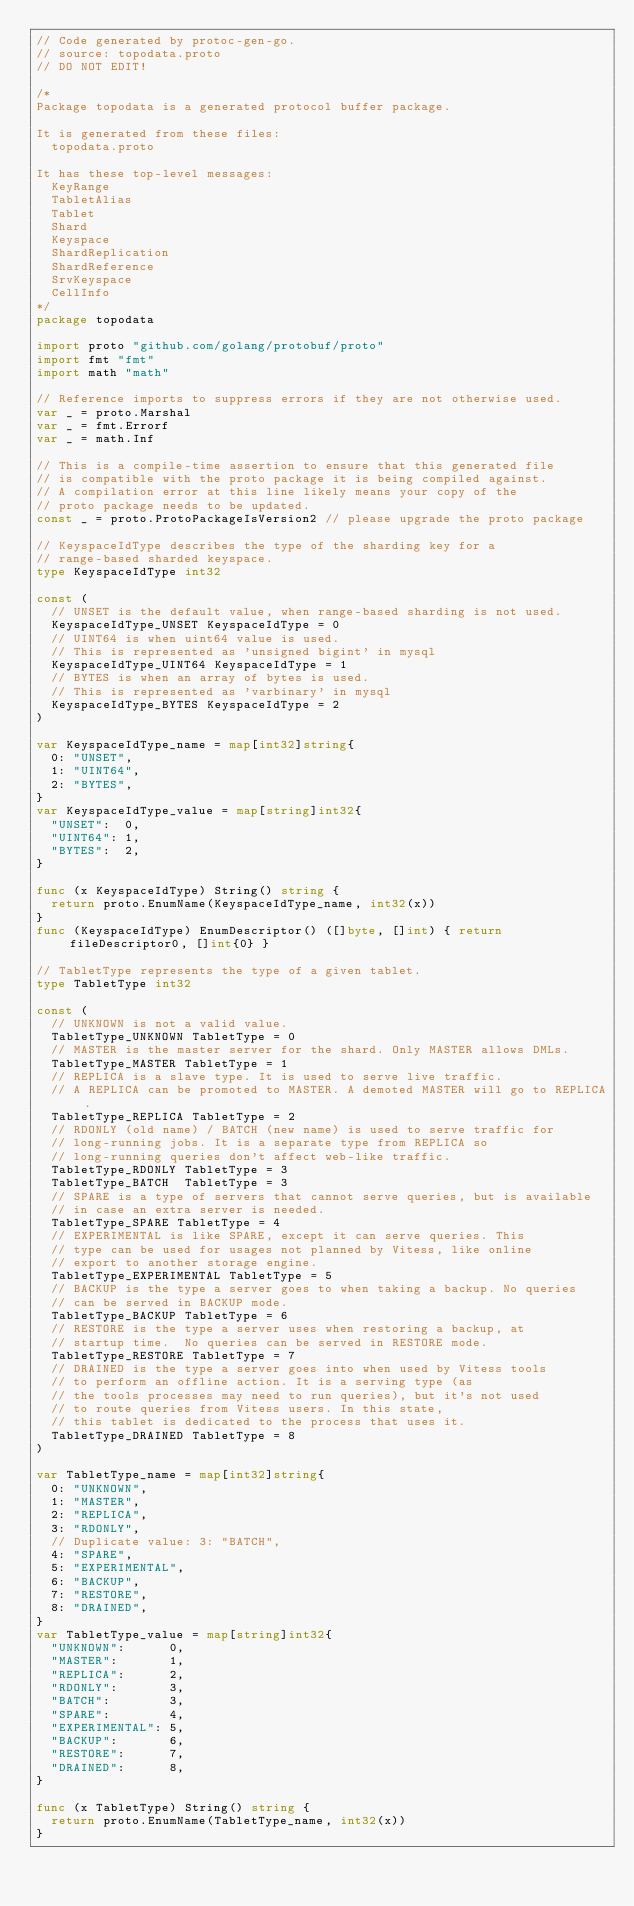Convert code to text. <code><loc_0><loc_0><loc_500><loc_500><_Go_>// Code generated by protoc-gen-go.
// source: topodata.proto
// DO NOT EDIT!

/*
Package topodata is a generated protocol buffer package.

It is generated from these files:
	topodata.proto

It has these top-level messages:
	KeyRange
	TabletAlias
	Tablet
	Shard
	Keyspace
	ShardReplication
	ShardReference
	SrvKeyspace
	CellInfo
*/
package topodata

import proto "github.com/golang/protobuf/proto"
import fmt "fmt"
import math "math"

// Reference imports to suppress errors if they are not otherwise used.
var _ = proto.Marshal
var _ = fmt.Errorf
var _ = math.Inf

// This is a compile-time assertion to ensure that this generated file
// is compatible with the proto package it is being compiled against.
// A compilation error at this line likely means your copy of the
// proto package needs to be updated.
const _ = proto.ProtoPackageIsVersion2 // please upgrade the proto package

// KeyspaceIdType describes the type of the sharding key for a
// range-based sharded keyspace.
type KeyspaceIdType int32

const (
	// UNSET is the default value, when range-based sharding is not used.
	KeyspaceIdType_UNSET KeyspaceIdType = 0
	// UINT64 is when uint64 value is used.
	// This is represented as 'unsigned bigint' in mysql
	KeyspaceIdType_UINT64 KeyspaceIdType = 1
	// BYTES is when an array of bytes is used.
	// This is represented as 'varbinary' in mysql
	KeyspaceIdType_BYTES KeyspaceIdType = 2
)

var KeyspaceIdType_name = map[int32]string{
	0: "UNSET",
	1: "UINT64",
	2: "BYTES",
}
var KeyspaceIdType_value = map[string]int32{
	"UNSET":  0,
	"UINT64": 1,
	"BYTES":  2,
}

func (x KeyspaceIdType) String() string {
	return proto.EnumName(KeyspaceIdType_name, int32(x))
}
func (KeyspaceIdType) EnumDescriptor() ([]byte, []int) { return fileDescriptor0, []int{0} }

// TabletType represents the type of a given tablet.
type TabletType int32

const (
	// UNKNOWN is not a valid value.
	TabletType_UNKNOWN TabletType = 0
	// MASTER is the master server for the shard. Only MASTER allows DMLs.
	TabletType_MASTER TabletType = 1
	// REPLICA is a slave type. It is used to serve live traffic.
	// A REPLICA can be promoted to MASTER. A demoted MASTER will go to REPLICA.
	TabletType_REPLICA TabletType = 2
	// RDONLY (old name) / BATCH (new name) is used to serve traffic for
	// long-running jobs. It is a separate type from REPLICA so
	// long-running queries don't affect web-like traffic.
	TabletType_RDONLY TabletType = 3
	TabletType_BATCH  TabletType = 3
	// SPARE is a type of servers that cannot serve queries, but is available
	// in case an extra server is needed.
	TabletType_SPARE TabletType = 4
	// EXPERIMENTAL is like SPARE, except it can serve queries. This
	// type can be used for usages not planned by Vitess, like online
	// export to another storage engine.
	TabletType_EXPERIMENTAL TabletType = 5
	// BACKUP is the type a server goes to when taking a backup. No queries
	// can be served in BACKUP mode.
	TabletType_BACKUP TabletType = 6
	// RESTORE is the type a server uses when restoring a backup, at
	// startup time.  No queries can be served in RESTORE mode.
	TabletType_RESTORE TabletType = 7
	// DRAINED is the type a server goes into when used by Vitess tools
	// to perform an offline action. It is a serving type (as
	// the tools processes may need to run queries), but it's not used
	// to route queries from Vitess users. In this state,
	// this tablet is dedicated to the process that uses it.
	TabletType_DRAINED TabletType = 8
)

var TabletType_name = map[int32]string{
	0: "UNKNOWN",
	1: "MASTER",
	2: "REPLICA",
	3: "RDONLY",
	// Duplicate value: 3: "BATCH",
	4: "SPARE",
	5: "EXPERIMENTAL",
	6: "BACKUP",
	7: "RESTORE",
	8: "DRAINED",
}
var TabletType_value = map[string]int32{
	"UNKNOWN":      0,
	"MASTER":       1,
	"REPLICA":      2,
	"RDONLY":       3,
	"BATCH":        3,
	"SPARE":        4,
	"EXPERIMENTAL": 5,
	"BACKUP":       6,
	"RESTORE":      7,
	"DRAINED":      8,
}

func (x TabletType) String() string {
	return proto.EnumName(TabletType_name, int32(x))
}</code> 